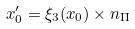Convert formula to latex. <formula><loc_0><loc_0><loc_500><loc_500>x _ { 0 } ^ { \prime } = \xi _ { 3 } ( x _ { 0 } ) \times n _ { \Pi }</formula> 